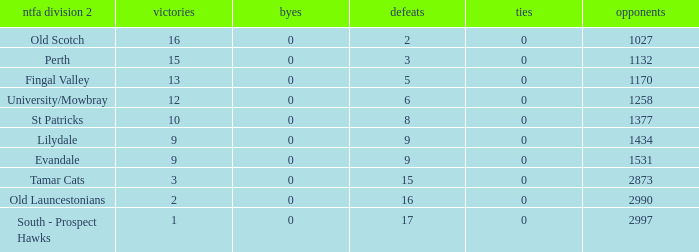What is the lowest number of against of NTFA Div 2 Fingal Valley? 1170.0. 